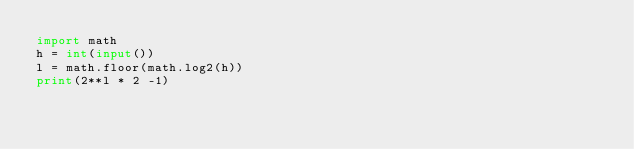<code> <loc_0><loc_0><loc_500><loc_500><_Python_>import math
h = int(input())
l = math.floor(math.log2(h))
print(2**l * 2 -1)</code> 